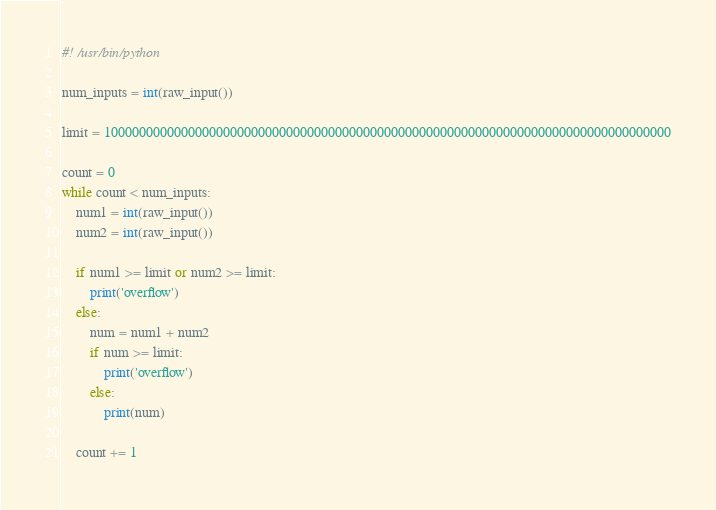<code> <loc_0><loc_0><loc_500><loc_500><_Python_>#! /usr/bin/python

num_inputs = int(raw_input())

limit = 100000000000000000000000000000000000000000000000000000000000000000000000000000000

count = 0
while count < num_inputs:
	num1 = int(raw_input())
	num2 = int(raw_input())

	if num1 >= limit or num2 >= limit:
		print('overflow')
	else:
		num = num1 + num2
		if num >= limit:
			print('overflow')
		else:
			print(num)

	count += 1</code> 